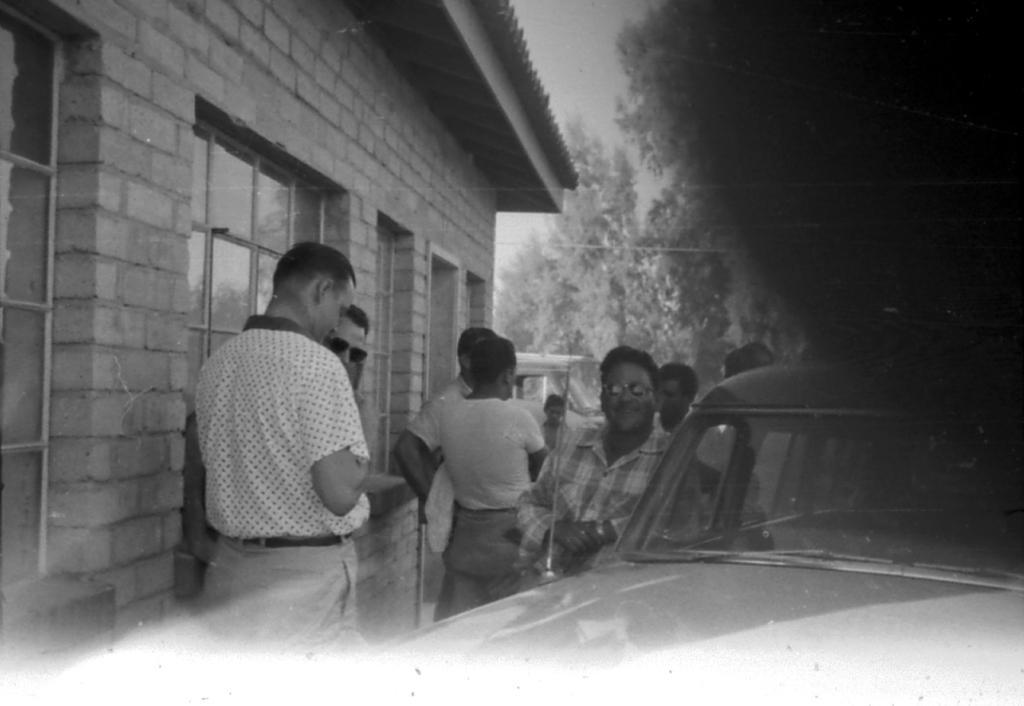In one or two sentences, can you explain what this image depicts? In this image I can see group of people standing, in front I can see a vehicle. Background I can see a building, trees and sky, and the image is in black and white. 